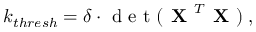Convert formula to latex. <formula><loc_0><loc_0><loc_500><loc_500>k _ { t h r e s h } = \delta \cdot d e t ( X ^ { T } X ) \, ,</formula> 